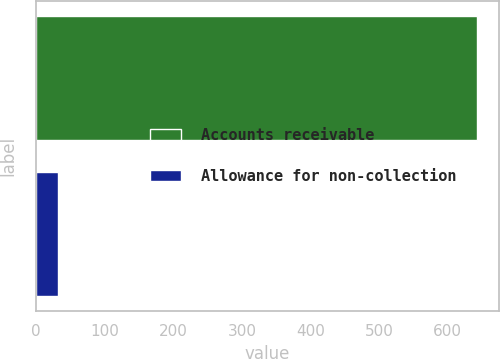Convert chart to OTSL. <chart><loc_0><loc_0><loc_500><loc_500><bar_chart><fcel>Accounts receivable<fcel>Allowance for non-collection<nl><fcel>643<fcel>32<nl></chart> 